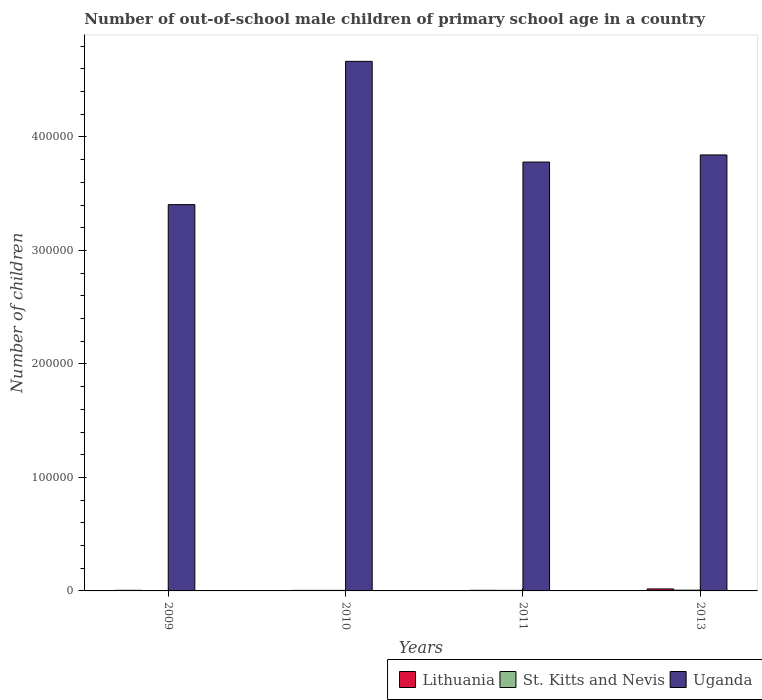How many bars are there on the 4th tick from the left?
Offer a very short reply. 3. How many bars are there on the 2nd tick from the right?
Provide a succinct answer. 3. What is the label of the 2nd group of bars from the left?
Provide a succinct answer. 2010. In how many cases, is the number of bars for a given year not equal to the number of legend labels?
Keep it short and to the point. 0. What is the number of out-of-school male children in St. Kitts and Nevis in 2011?
Provide a succinct answer. 471. Across all years, what is the maximum number of out-of-school male children in St. Kitts and Nevis?
Your answer should be compact. 649. Across all years, what is the minimum number of out-of-school male children in Uganda?
Offer a terse response. 3.40e+05. In which year was the number of out-of-school male children in St. Kitts and Nevis minimum?
Ensure brevity in your answer.  2009. What is the total number of out-of-school male children in St. Kitts and Nevis in the graph?
Provide a short and direct response. 1903. What is the difference between the number of out-of-school male children in Lithuania in 2009 and that in 2013?
Your response must be concise. -1224. What is the difference between the number of out-of-school male children in Uganda in 2011 and the number of out-of-school male children in Lithuania in 2009?
Your answer should be very brief. 3.77e+05. What is the average number of out-of-school male children in Uganda per year?
Offer a terse response. 3.92e+05. In the year 2011, what is the difference between the number of out-of-school male children in St. Kitts and Nevis and number of out-of-school male children in Uganda?
Offer a terse response. -3.77e+05. What is the ratio of the number of out-of-school male children in Uganda in 2011 to that in 2013?
Offer a very short reply. 0.98. Is the difference between the number of out-of-school male children in St. Kitts and Nevis in 2011 and 2013 greater than the difference between the number of out-of-school male children in Uganda in 2011 and 2013?
Your response must be concise. Yes. What is the difference between the highest and the second highest number of out-of-school male children in Lithuania?
Give a very brief answer. 1219. What is the difference between the highest and the lowest number of out-of-school male children in Uganda?
Provide a short and direct response. 1.26e+05. Is the sum of the number of out-of-school male children in Lithuania in 2010 and 2011 greater than the maximum number of out-of-school male children in Uganda across all years?
Your answer should be very brief. No. What does the 3rd bar from the left in 2013 represents?
Ensure brevity in your answer.  Uganda. What does the 3rd bar from the right in 2011 represents?
Keep it short and to the point. Lithuania. Is it the case that in every year, the sum of the number of out-of-school male children in Uganda and number of out-of-school male children in Lithuania is greater than the number of out-of-school male children in St. Kitts and Nevis?
Ensure brevity in your answer.  Yes. How many bars are there?
Keep it short and to the point. 12. Are all the bars in the graph horizontal?
Make the answer very short. No. Are the values on the major ticks of Y-axis written in scientific E-notation?
Offer a very short reply. No. Does the graph contain any zero values?
Offer a very short reply. No. Does the graph contain grids?
Offer a terse response. No. How are the legend labels stacked?
Offer a terse response. Horizontal. What is the title of the graph?
Give a very brief answer. Number of out-of-school male children of primary school age in a country. What is the label or title of the Y-axis?
Provide a succinct answer. Number of children. What is the Number of children of Lithuania in 2009?
Provide a succinct answer. 521. What is the Number of children in St. Kitts and Nevis in 2009?
Your answer should be compact. 302. What is the Number of children in Uganda in 2009?
Offer a terse response. 3.40e+05. What is the Number of children of Lithuania in 2010?
Ensure brevity in your answer.  476. What is the Number of children of St. Kitts and Nevis in 2010?
Offer a very short reply. 481. What is the Number of children in Uganda in 2010?
Ensure brevity in your answer.  4.67e+05. What is the Number of children in Lithuania in 2011?
Provide a succinct answer. 526. What is the Number of children in St. Kitts and Nevis in 2011?
Provide a short and direct response. 471. What is the Number of children in Uganda in 2011?
Keep it short and to the point. 3.78e+05. What is the Number of children of Lithuania in 2013?
Your answer should be very brief. 1745. What is the Number of children of St. Kitts and Nevis in 2013?
Keep it short and to the point. 649. What is the Number of children in Uganda in 2013?
Your answer should be compact. 3.84e+05. Across all years, what is the maximum Number of children in Lithuania?
Offer a terse response. 1745. Across all years, what is the maximum Number of children in St. Kitts and Nevis?
Provide a short and direct response. 649. Across all years, what is the maximum Number of children of Uganda?
Your answer should be very brief. 4.67e+05. Across all years, what is the minimum Number of children of Lithuania?
Ensure brevity in your answer.  476. Across all years, what is the minimum Number of children of St. Kitts and Nevis?
Offer a terse response. 302. Across all years, what is the minimum Number of children in Uganda?
Offer a terse response. 3.40e+05. What is the total Number of children of Lithuania in the graph?
Your answer should be very brief. 3268. What is the total Number of children in St. Kitts and Nevis in the graph?
Provide a succinct answer. 1903. What is the total Number of children of Uganda in the graph?
Keep it short and to the point. 1.57e+06. What is the difference between the Number of children in Lithuania in 2009 and that in 2010?
Offer a very short reply. 45. What is the difference between the Number of children in St. Kitts and Nevis in 2009 and that in 2010?
Ensure brevity in your answer.  -179. What is the difference between the Number of children in Uganda in 2009 and that in 2010?
Ensure brevity in your answer.  -1.26e+05. What is the difference between the Number of children in Lithuania in 2009 and that in 2011?
Provide a short and direct response. -5. What is the difference between the Number of children of St. Kitts and Nevis in 2009 and that in 2011?
Offer a terse response. -169. What is the difference between the Number of children in Uganda in 2009 and that in 2011?
Your answer should be compact. -3.75e+04. What is the difference between the Number of children of Lithuania in 2009 and that in 2013?
Your answer should be very brief. -1224. What is the difference between the Number of children of St. Kitts and Nevis in 2009 and that in 2013?
Your response must be concise. -347. What is the difference between the Number of children of Uganda in 2009 and that in 2013?
Keep it short and to the point. -4.38e+04. What is the difference between the Number of children of Uganda in 2010 and that in 2011?
Your answer should be compact. 8.87e+04. What is the difference between the Number of children of Lithuania in 2010 and that in 2013?
Your response must be concise. -1269. What is the difference between the Number of children in St. Kitts and Nevis in 2010 and that in 2013?
Make the answer very short. -168. What is the difference between the Number of children of Uganda in 2010 and that in 2013?
Your answer should be very brief. 8.25e+04. What is the difference between the Number of children in Lithuania in 2011 and that in 2013?
Provide a succinct answer. -1219. What is the difference between the Number of children of St. Kitts and Nevis in 2011 and that in 2013?
Your answer should be very brief. -178. What is the difference between the Number of children of Uganda in 2011 and that in 2013?
Provide a short and direct response. -6261. What is the difference between the Number of children of Lithuania in 2009 and the Number of children of Uganda in 2010?
Your response must be concise. -4.66e+05. What is the difference between the Number of children of St. Kitts and Nevis in 2009 and the Number of children of Uganda in 2010?
Provide a short and direct response. -4.66e+05. What is the difference between the Number of children of Lithuania in 2009 and the Number of children of Uganda in 2011?
Your answer should be very brief. -3.77e+05. What is the difference between the Number of children of St. Kitts and Nevis in 2009 and the Number of children of Uganda in 2011?
Provide a short and direct response. -3.78e+05. What is the difference between the Number of children in Lithuania in 2009 and the Number of children in St. Kitts and Nevis in 2013?
Make the answer very short. -128. What is the difference between the Number of children in Lithuania in 2009 and the Number of children in Uganda in 2013?
Offer a terse response. -3.84e+05. What is the difference between the Number of children in St. Kitts and Nevis in 2009 and the Number of children in Uganda in 2013?
Ensure brevity in your answer.  -3.84e+05. What is the difference between the Number of children in Lithuania in 2010 and the Number of children in Uganda in 2011?
Your answer should be compact. -3.77e+05. What is the difference between the Number of children of St. Kitts and Nevis in 2010 and the Number of children of Uganda in 2011?
Ensure brevity in your answer.  -3.77e+05. What is the difference between the Number of children in Lithuania in 2010 and the Number of children in St. Kitts and Nevis in 2013?
Provide a succinct answer. -173. What is the difference between the Number of children in Lithuania in 2010 and the Number of children in Uganda in 2013?
Give a very brief answer. -3.84e+05. What is the difference between the Number of children in St. Kitts and Nevis in 2010 and the Number of children in Uganda in 2013?
Make the answer very short. -3.84e+05. What is the difference between the Number of children in Lithuania in 2011 and the Number of children in St. Kitts and Nevis in 2013?
Your response must be concise. -123. What is the difference between the Number of children in Lithuania in 2011 and the Number of children in Uganda in 2013?
Your answer should be compact. -3.84e+05. What is the difference between the Number of children in St. Kitts and Nevis in 2011 and the Number of children in Uganda in 2013?
Give a very brief answer. -3.84e+05. What is the average Number of children in Lithuania per year?
Ensure brevity in your answer.  817. What is the average Number of children in St. Kitts and Nevis per year?
Provide a short and direct response. 475.75. What is the average Number of children in Uganda per year?
Provide a succinct answer. 3.92e+05. In the year 2009, what is the difference between the Number of children in Lithuania and Number of children in St. Kitts and Nevis?
Provide a short and direct response. 219. In the year 2009, what is the difference between the Number of children in Lithuania and Number of children in Uganda?
Your answer should be compact. -3.40e+05. In the year 2009, what is the difference between the Number of children of St. Kitts and Nevis and Number of children of Uganda?
Keep it short and to the point. -3.40e+05. In the year 2010, what is the difference between the Number of children in Lithuania and Number of children in St. Kitts and Nevis?
Keep it short and to the point. -5. In the year 2010, what is the difference between the Number of children in Lithuania and Number of children in Uganda?
Your answer should be compact. -4.66e+05. In the year 2010, what is the difference between the Number of children of St. Kitts and Nevis and Number of children of Uganda?
Ensure brevity in your answer.  -4.66e+05. In the year 2011, what is the difference between the Number of children of Lithuania and Number of children of St. Kitts and Nevis?
Provide a succinct answer. 55. In the year 2011, what is the difference between the Number of children in Lithuania and Number of children in Uganda?
Make the answer very short. -3.77e+05. In the year 2011, what is the difference between the Number of children in St. Kitts and Nevis and Number of children in Uganda?
Your answer should be compact. -3.77e+05. In the year 2013, what is the difference between the Number of children of Lithuania and Number of children of St. Kitts and Nevis?
Offer a terse response. 1096. In the year 2013, what is the difference between the Number of children in Lithuania and Number of children in Uganda?
Keep it short and to the point. -3.82e+05. In the year 2013, what is the difference between the Number of children in St. Kitts and Nevis and Number of children in Uganda?
Your answer should be compact. -3.84e+05. What is the ratio of the Number of children in Lithuania in 2009 to that in 2010?
Provide a short and direct response. 1.09. What is the ratio of the Number of children of St. Kitts and Nevis in 2009 to that in 2010?
Your answer should be very brief. 0.63. What is the ratio of the Number of children of Uganda in 2009 to that in 2010?
Make the answer very short. 0.73. What is the ratio of the Number of children of Lithuania in 2009 to that in 2011?
Offer a terse response. 0.99. What is the ratio of the Number of children of St. Kitts and Nevis in 2009 to that in 2011?
Keep it short and to the point. 0.64. What is the ratio of the Number of children in Uganda in 2009 to that in 2011?
Offer a very short reply. 0.9. What is the ratio of the Number of children in Lithuania in 2009 to that in 2013?
Your answer should be compact. 0.3. What is the ratio of the Number of children of St. Kitts and Nevis in 2009 to that in 2013?
Keep it short and to the point. 0.47. What is the ratio of the Number of children in Uganda in 2009 to that in 2013?
Offer a very short reply. 0.89. What is the ratio of the Number of children in Lithuania in 2010 to that in 2011?
Your response must be concise. 0.9. What is the ratio of the Number of children in St. Kitts and Nevis in 2010 to that in 2011?
Your answer should be very brief. 1.02. What is the ratio of the Number of children in Uganda in 2010 to that in 2011?
Ensure brevity in your answer.  1.23. What is the ratio of the Number of children of Lithuania in 2010 to that in 2013?
Offer a very short reply. 0.27. What is the ratio of the Number of children of St. Kitts and Nevis in 2010 to that in 2013?
Your answer should be very brief. 0.74. What is the ratio of the Number of children in Uganda in 2010 to that in 2013?
Give a very brief answer. 1.21. What is the ratio of the Number of children of Lithuania in 2011 to that in 2013?
Provide a short and direct response. 0.3. What is the ratio of the Number of children in St. Kitts and Nevis in 2011 to that in 2013?
Your response must be concise. 0.73. What is the ratio of the Number of children in Uganda in 2011 to that in 2013?
Your response must be concise. 0.98. What is the difference between the highest and the second highest Number of children of Lithuania?
Give a very brief answer. 1219. What is the difference between the highest and the second highest Number of children in St. Kitts and Nevis?
Your answer should be compact. 168. What is the difference between the highest and the second highest Number of children in Uganda?
Offer a very short reply. 8.25e+04. What is the difference between the highest and the lowest Number of children in Lithuania?
Offer a terse response. 1269. What is the difference between the highest and the lowest Number of children of St. Kitts and Nevis?
Give a very brief answer. 347. What is the difference between the highest and the lowest Number of children in Uganda?
Ensure brevity in your answer.  1.26e+05. 